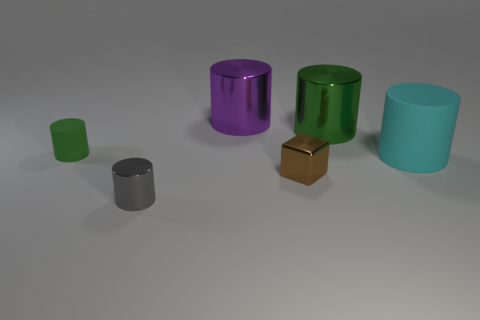Add 1 purple metal cylinders. How many objects exist? 7 Subtract all green cylinders. How many cylinders are left? 3 Subtract all large green cylinders. How many cylinders are left? 4 Subtract 0 yellow blocks. How many objects are left? 6 Subtract all blocks. How many objects are left? 5 Subtract 2 cylinders. How many cylinders are left? 3 Subtract all gray blocks. Subtract all brown spheres. How many blocks are left? 1 Subtract all cyan spheres. How many gray cylinders are left? 1 Subtract all tiny brown shiny objects. Subtract all large red rubber cubes. How many objects are left? 5 Add 5 big green shiny cylinders. How many big green shiny cylinders are left? 6 